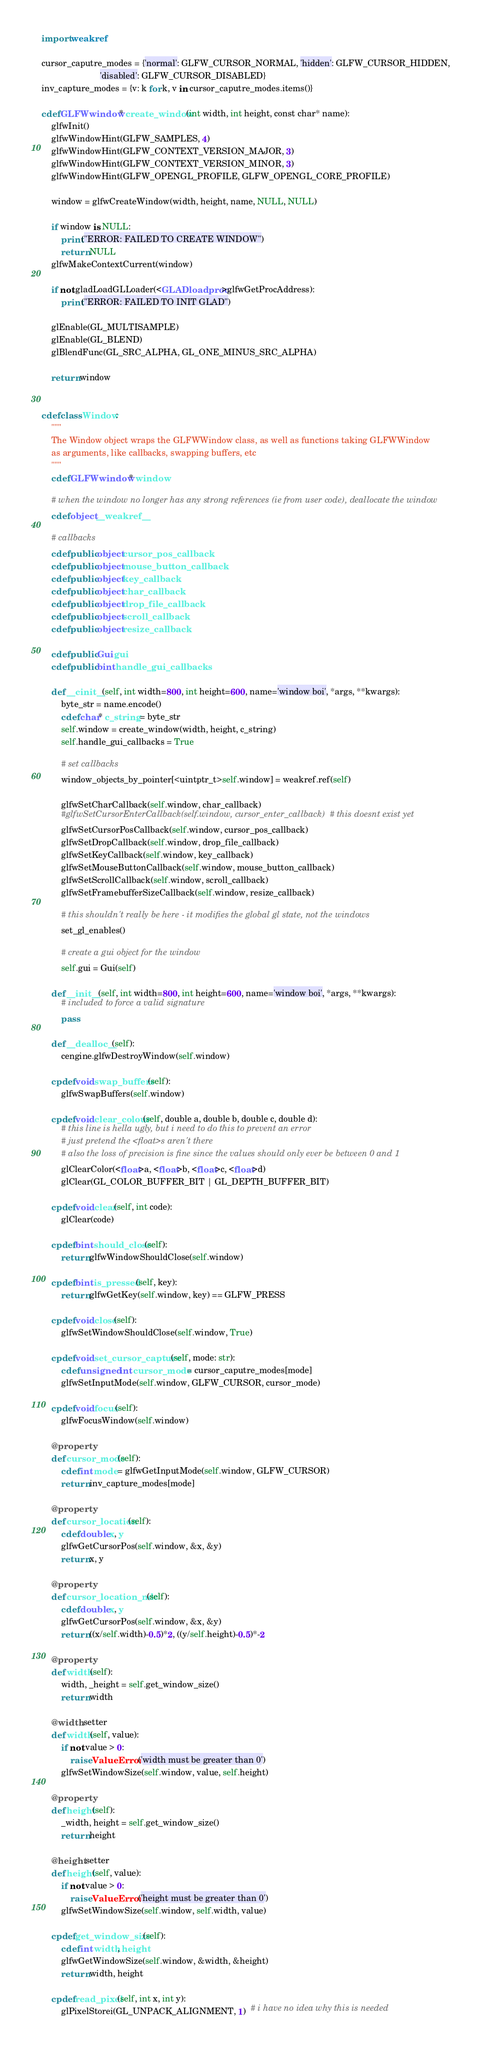Convert code to text. <code><loc_0><loc_0><loc_500><loc_500><_Cython_>import weakref

cursor_caputre_modes = {'normal': GLFW_CURSOR_NORMAL, 'hidden': GLFW_CURSOR_HIDDEN,
                        'disabled': GLFW_CURSOR_DISABLED}
inv_capture_modes = {v: k for k, v in cursor_caputre_modes.items()}

cdef GLFWwindow* create_window(int width, int height, const char* name):
    glfwInit()
    glfwWindowHint(GLFW_SAMPLES, 4)
    glfwWindowHint(GLFW_CONTEXT_VERSION_MAJOR, 3)
    glfwWindowHint(GLFW_CONTEXT_VERSION_MINOR, 3)
    glfwWindowHint(GLFW_OPENGL_PROFILE, GLFW_OPENGL_CORE_PROFILE)

    window = glfwCreateWindow(width, height, name, NULL, NULL)

    if window is NULL:
        print("ERROR: FAILED TO CREATE WINDOW")
        return NULL
    glfwMakeContextCurrent(window)

    if not gladLoadGLLoader(<GLADloadproc>glfwGetProcAddress):
        print("ERROR: FAILED TO INIT GLAD")

    glEnable(GL_MULTISAMPLE)
    glEnable(GL_BLEND)
    glBlendFunc(GL_SRC_ALPHA, GL_ONE_MINUS_SRC_ALPHA)

    return window


cdef class Window:
    """
    The Window object wraps the GLFWWindow class, as well as functions taking GLFWWindow
    as arguments, like callbacks, swapping buffers, etc
    """
    cdef GLFWwindow* window

    # when the window no longer has any strong references (ie from user code), deallocate the window
    cdef object __weakref__

    # callbacks
    cdef public object cursor_pos_callback
    cdef public object mouse_button_callback
    cdef public object key_callback
    cdef public object char_callback
    cdef public object drop_file_callback
    cdef public object scroll_callback
    cdef public object resize_callback

    cdef public Gui gui
    cdef public bint handle_gui_callbacks

    def __cinit__(self, int width=800, int height=600, name='window boi', *args, **kwargs):
        byte_str = name.encode()
        cdef char* c_string = byte_str
        self.window = create_window(width, height, c_string)
        self.handle_gui_callbacks = True

        # set callbacks
        window_objects_by_pointer[<uintptr_t>self.window] = weakref.ref(self)

        glfwSetCharCallback(self.window, char_callback)
        #glfwSetCursorEnterCallback(self.window, cursor_enter_callback)  # this doesnt exist yet
        glfwSetCursorPosCallback(self.window, cursor_pos_callback)
        glfwSetDropCallback(self.window, drop_file_callback)
        glfwSetKeyCallback(self.window, key_callback)
        glfwSetMouseButtonCallback(self.window, mouse_button_callback)
        glfwSetScrollCallback(self.window, scroll_callback)
        glfwSetFramebufferSizeCallback(self.window, resize_callback)

        # this shouldn't really be here - it modifies the global gl state, not the windows
        set_gl_enables()

        # create a gui object for the window
        self.gui = Gui(self)

    def __init__(self, int width=800, int height=600, name='window boi', *args, **kwargs):
        # included to force a valid signature
        pass

    def __dealloc__(self):
        cengine.glfwDestroyWindow(self.window)

    cpdef void swap_buffers(self):
        glfwSwapBuffers(self.window)

    cpdef void clear_colour(self, double a, double b, double c, double d):
        # this line is hella ugly, but i need to do this to prevent an error
        # just pretend the <float>s aren't there
        # also the loss of precision is fine since the values should only ever be between 0 and 1
        glClearColor(<float>a, <float>b, <float>c, <float>d)
        glClear(GL_COLOR_BUFFER_BIT | GL_DEPTH_BUFFER_BIT)

    cpdef void clear(self, int code):
        glClear(code)

    cpdef bint should_close(self):
        return glfwWindowShouldClose(self.window)

    cpdef bint is_pressed(self, key):
        return glfwGetKey(self.window, key) == GLFW_PRESS

    cpdef void close(self):
        glfwSetWindowShouldClose(self.window, True)

    cpdef void set_cursor_capture(self, mode: str):
        cdef unsigned int cursor_mode = cursor_caputre_modes[mode]
        glfwSetInputMode(self.window, GLFW_CURSOR, cursor_mode)

    cpdef void focus(self):
        glfwFocusWindow(self.window)

    @property
    def cursor_mode(self):
        cdef int mode = glfwGetInputMode(self.window, GLFW_CURSOR)
        return inv_capture_modes[mode]

    @property
    def cursor_location(self):
        cdef double x, y
        glfwGetCursorPos(self.window, &x, &y)
        return x, y

    @property
    def cursor_location_ndc(self):
        cdef double x, y
        glfwGetCursorPos(self.window, &x, &y)
        return ((x/self.width)-0.5)*2, ((y/self.height)-0.5)*-2

    @property
    def width(self):
        width, _height = self.get_window_size()
        return width

    @width.setter
    def width(self, value):
        if not value > 0:
            raise ValueError('width must be greater than 0')
        glfwSetWindowSize(self.window, value, self.height)

    @property
    def height(self):
        _width, height = self.get_window_size()
        return height

    @height.setter
    def height(self, value):
        if not value > 0:
            raise ValueError('height must be greater than 0')
        glfwSetWindowSize(self.window, self.width, value)

    cpdef get_window_size(self):
        cdef int width, height
        glfwGetWindowSize(self.window, &width, &height)
        return width, height

    cpdef read_pixel(self, int x, int y):
        glPixelStorei(GL_UNPACK_ALIGNMENT, 1)  # i have no idea why this is needed</code> 